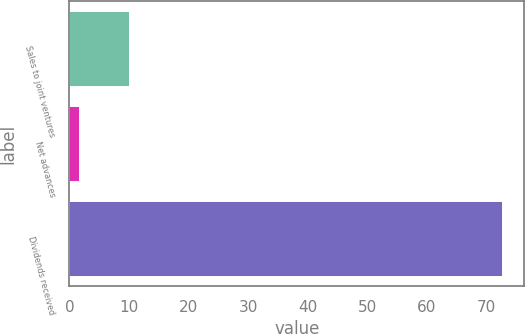Convert chart to OTSL. <chart><loc_0><loc_0><loc_500><loc_500><bar_chart><fcel>Sales to joint ventures<fcel>Net advances<fcel>Dividends received<nl><fcel>10.2<fcel>1.8<fcel>72.7<nl></chart> 